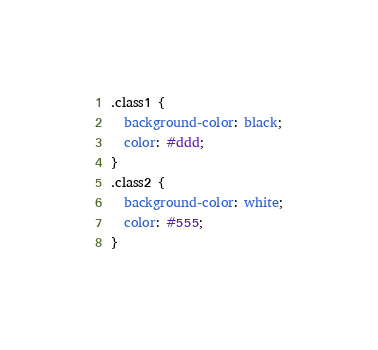<code> <loc_0><loc_0><loc_500><loc_500><_CSS_>.class1 {
  background-color: black;
  color: #ddd;
}
.class2 {
  background-color: white;
  color: #555;
}
</code> 